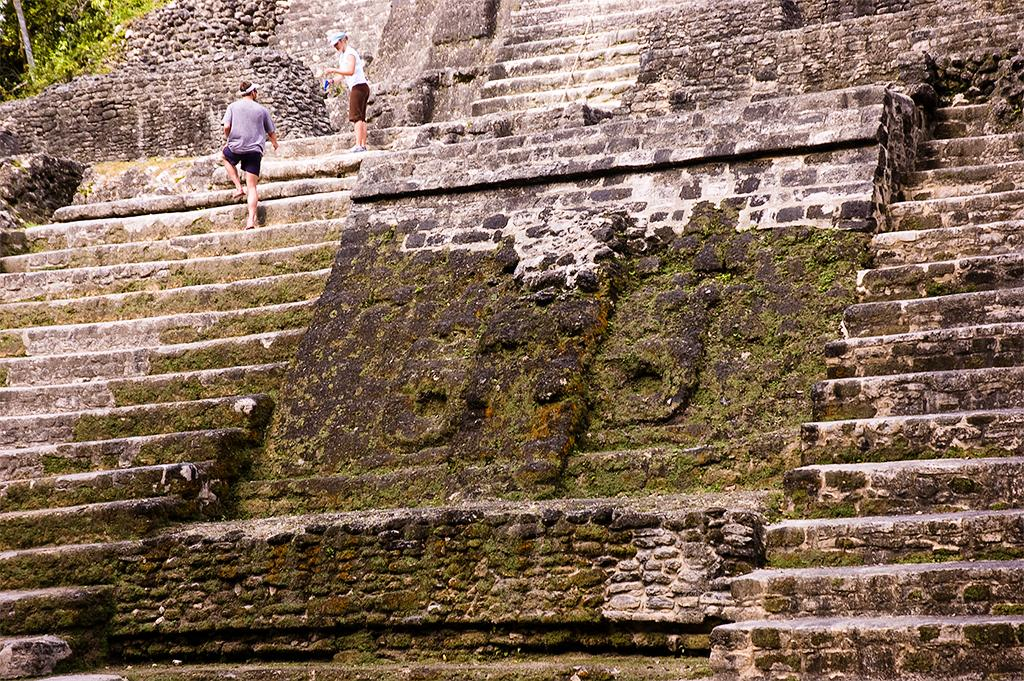What can be seen in the image that people use to move between different levels? There are steps in the image that people use to move between different levels. How many people are standing on the steps in the image? Two persons are standing on the steps in the image. What type of vegetation is visible in the top left corner of the image? There are trees in the top left corner of the image. What type of powder is being used by the persons standing on the steps in the image? There is no powder visible in the image, and the persons standing on the steps are not using any powder. 